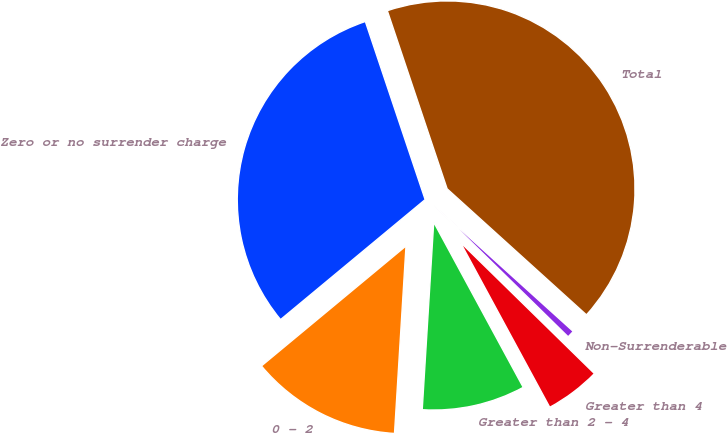Convert chart to OTSL. <chart><loc_0><loc_0><loc_500><loc_500><pie_chart><fcel>Zero or no surrender charge<fcel>0 - 2<fcel>Greater than 2 - 4<fcel>Greater than 4<fcel>Non-Surrenderable<fcel>Total<nl><fcel>30.87%<fcel>13.0%<fcel>8.88%<fcel>4.76%<fcel>0.63%<fcel>41.86%<nl></chart> 